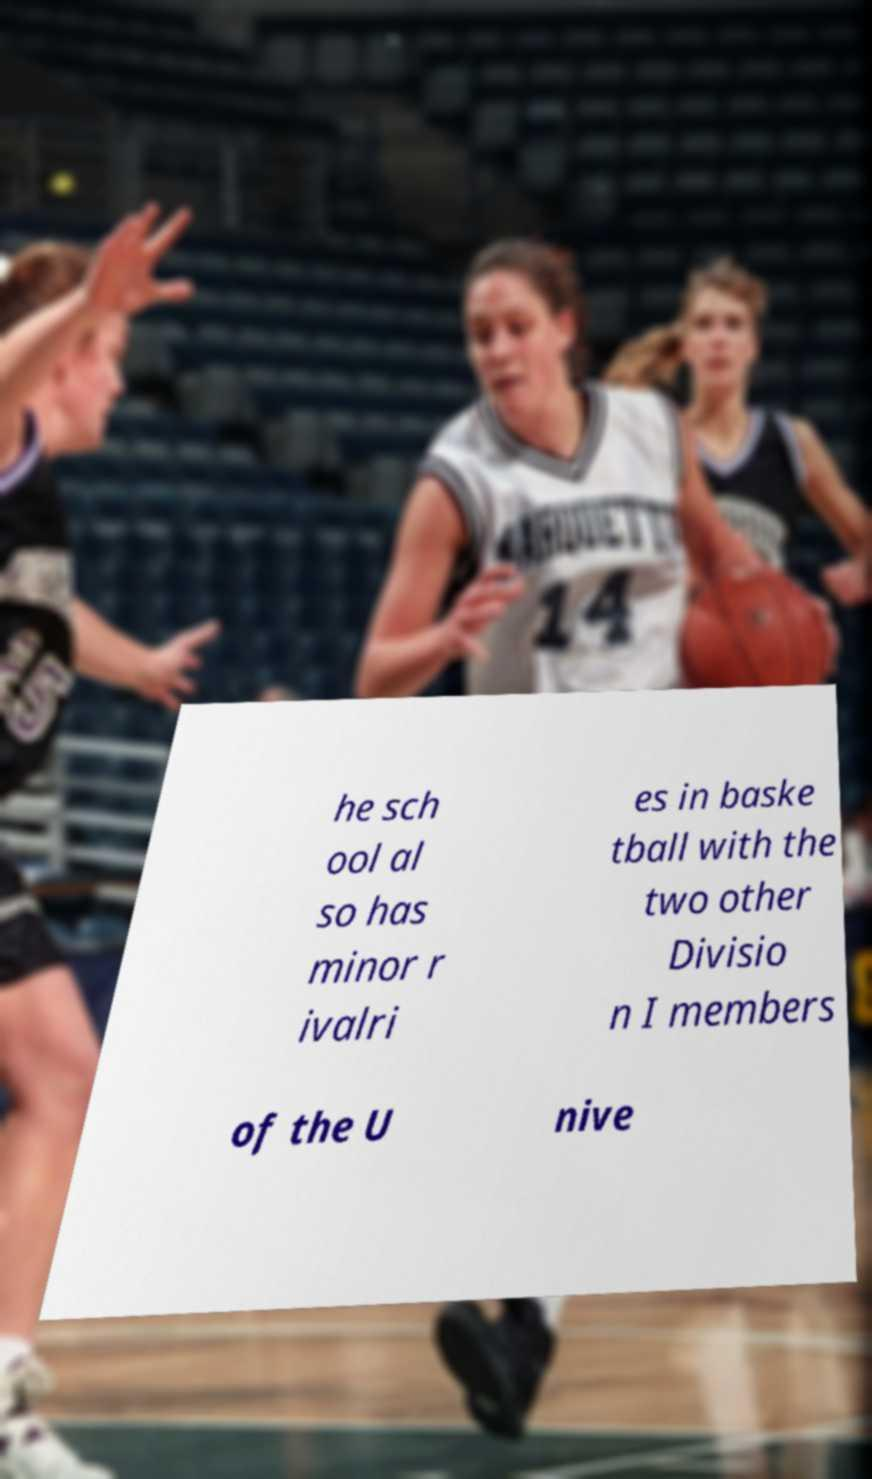Can you accurately transcribe the text from the provided image for me? he sch ool al so has minor r ivalri es in baske tball with the two other Divisio n I members of the U nive 